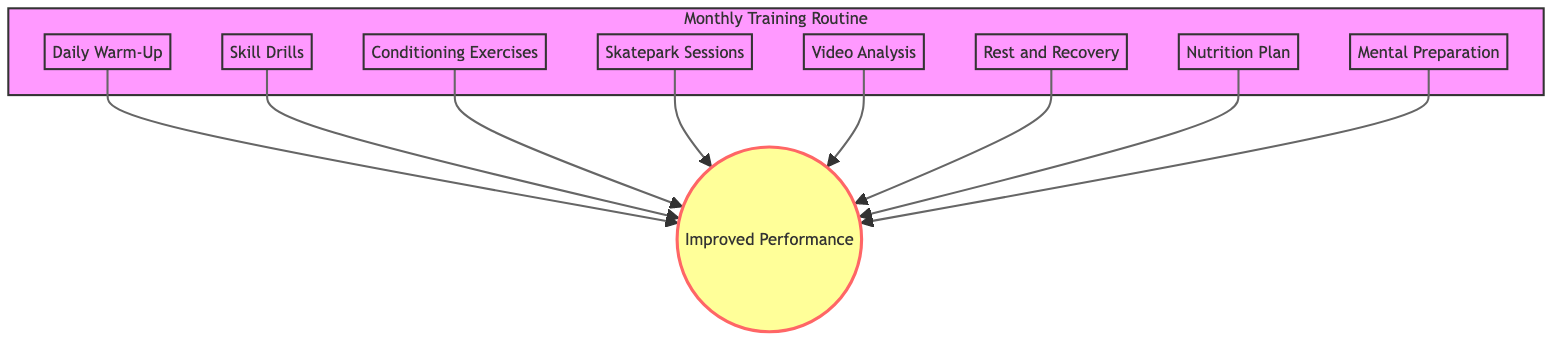What is the first step in the training routine? The first step listed in the diagram is "Daily Warm-Up." It is located at the top of the flowchart, indicating it is the initial activity before other routines.
Answer: Daily Warm-Up How many elements are there in the training routine? The diagram lists a total of eight different elements. Each element can be counted directly from the nodes in the flowchart.
Answer: Eight Which two elements focus on physical conditioning? The two elements that focus on conditioning are "Conditioning Exercises" and "Daily Warm-Up." Both contribute to preparing the body physically for performance.
Answer: Conditioning Exercises, Daily Warm-Up What is the result of engaging in these training exercises? The outcome of participating in all these exercises is represented by the node labeled "Improved Performance." It connects to all elements in the flowchart, signifying the shared goal.
Answer: Improved Performance Which element is related to analyzing past performances? The element related to analyzing past performances is "Video Analysis." This node specifically addresses reviewing recordings to find strengths and weaknesses.
Answer: Video Analysis What two elements emphasize mental preparation? The two elements that emphasize mental preparation are "Mental Preparation" and "Rest and Recovery." They support mental focus and recovery, which is vital for performance.
Answer: Mental Preparation, Rest and Recovery Identify the element that deals with nutrition. The element that deals with nutrition is "Nutrition Plan." This node is focused on dietary strategies to enhance training performance.
Answer: Nutrition Plan How do “Rest and Recovery” and “Nutrition Plan” contribute to the overall training objective? Both “Rest and Recovery” and “Nutrition Plan” are crucial in supporting the body’s readiness for training. They indirectly lead to "Improved Performance" by ensuring the athlete is fit and well-nourished.
Answer: Improved Performance 